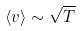<formula> <loc_0><loc_0><loc_500><loc_500>\langle v \rangle \sim \sqrt { T }</formula> 